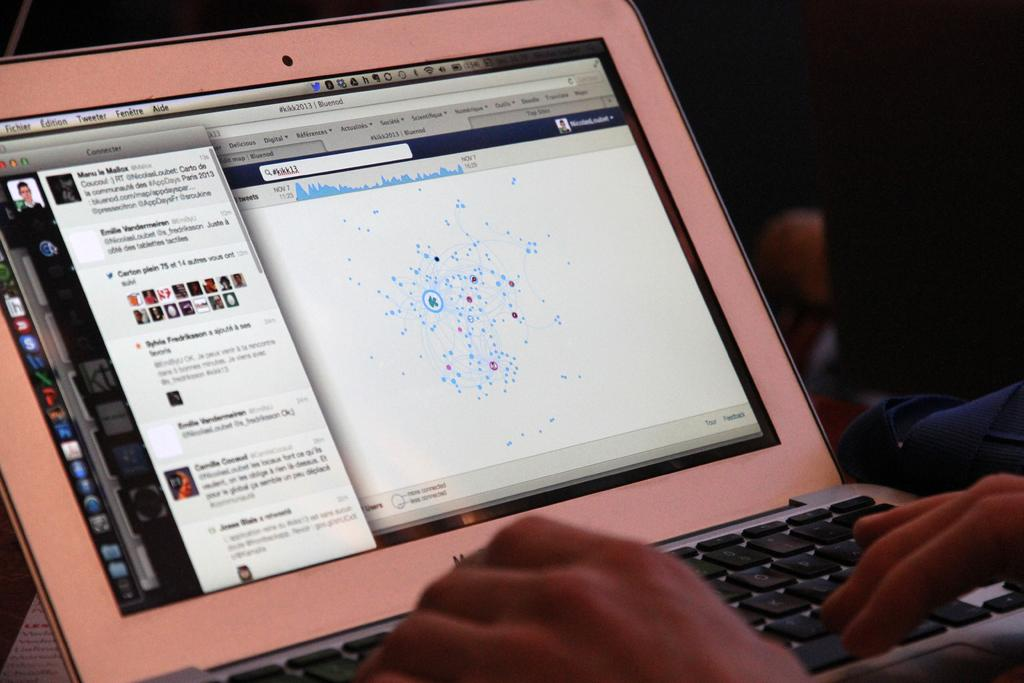What electronic device is present in the image? There is a laptop in the image. What part of the laptop is visible in the image? The laptop screen and key buttons are visible in the image. What is interacting with the laptop in the image? Human fingers are visible in the image. How would you describe the lighting in the image? The background of the image is dark. What type of dress is the giraffe wearing in the image? There is no giraffe or dress present in the image. Who is the friend sitting next to the laptop in the image? There is no friend visible in the image; only the laptop and human fingers are present. 